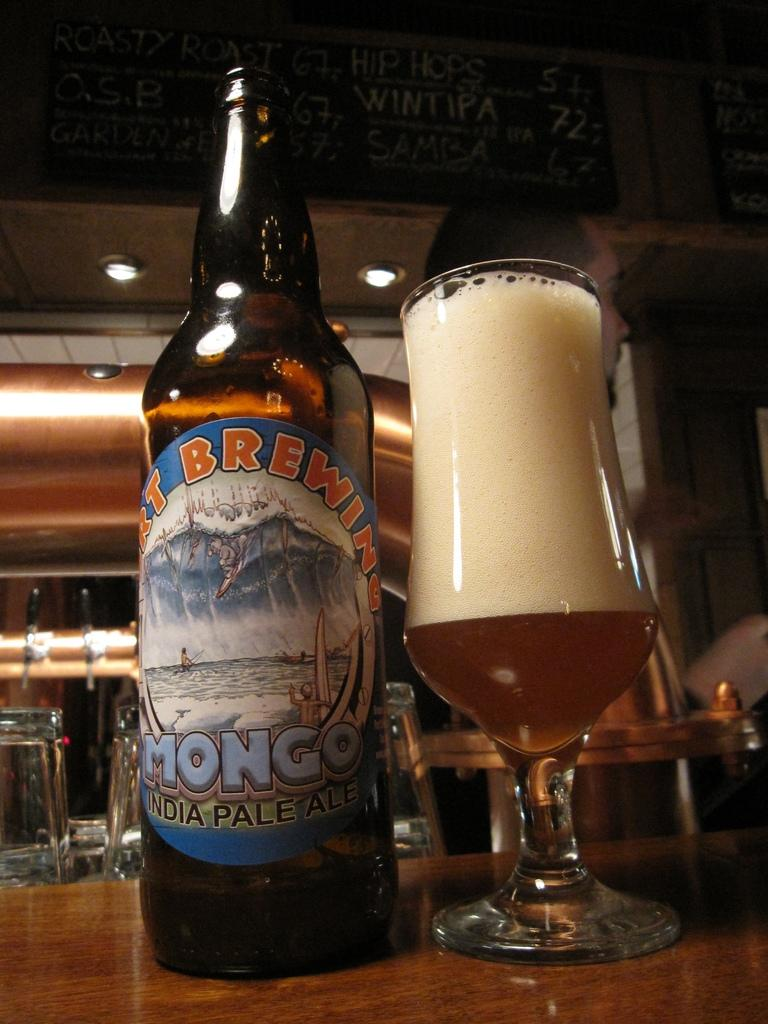<image>
Render a clear and concise summary of the photo. A bottle of Mongo pale ale sits by a foamy glass of beer in a bar. 